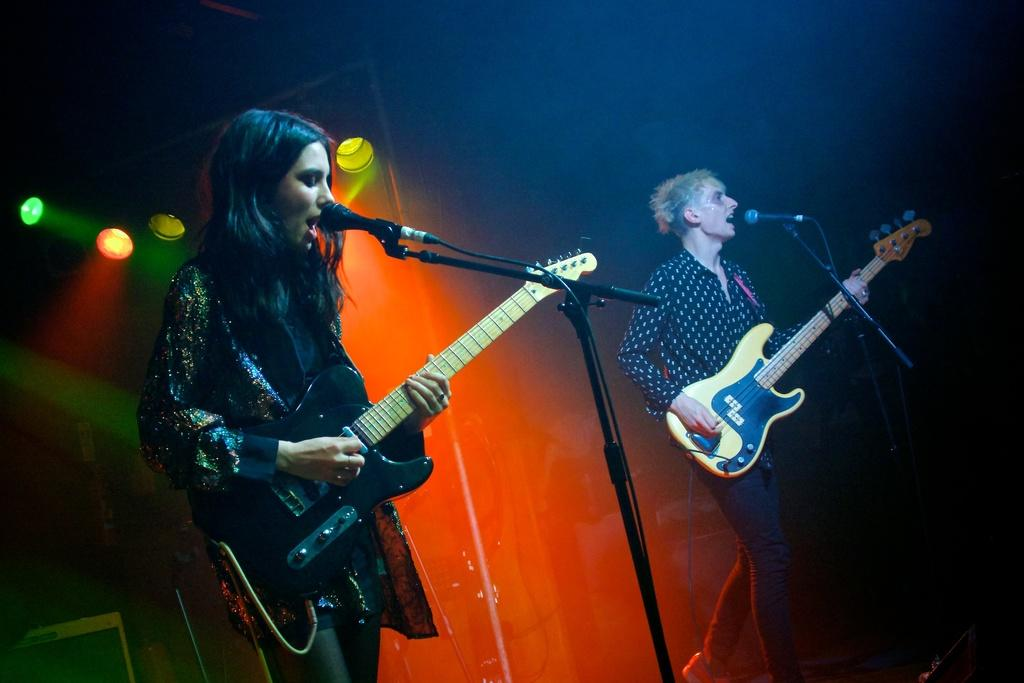How many people are in the image? There are 2 people in the image. What are the people doing in the image? The people are standing and singing in the image. What instrument is one of the people playing? One person is playing a guitar in the image. What equipment is present to amplify their voices? There are microphones present in front of the people in the image. What can be seen at the back of the scene? There are lights at the back of the scene in the image. What type of home can be seen in the background of the image? There is no home visible in the image; it features two people singing and playing a guitar with microphones and lights in the background. How does the son contribute to the performance in the image? There is no son present in the image, nor is there any indication of a performance involving a son. 